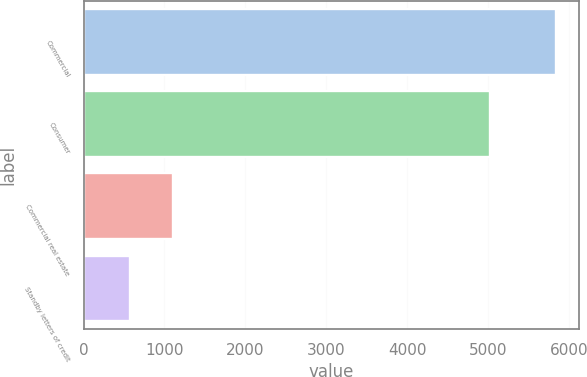<chart> <loc_0><loc_0><loc_500><loc_500><bar_chart><fcel>Commercial<fcel>Consumer<fcel>Commercial real estate<fcel>Standby letters of credit<nl><fcel>5834<fcel>5028<fcel>1102.7<fcel>577<nl></chart> 